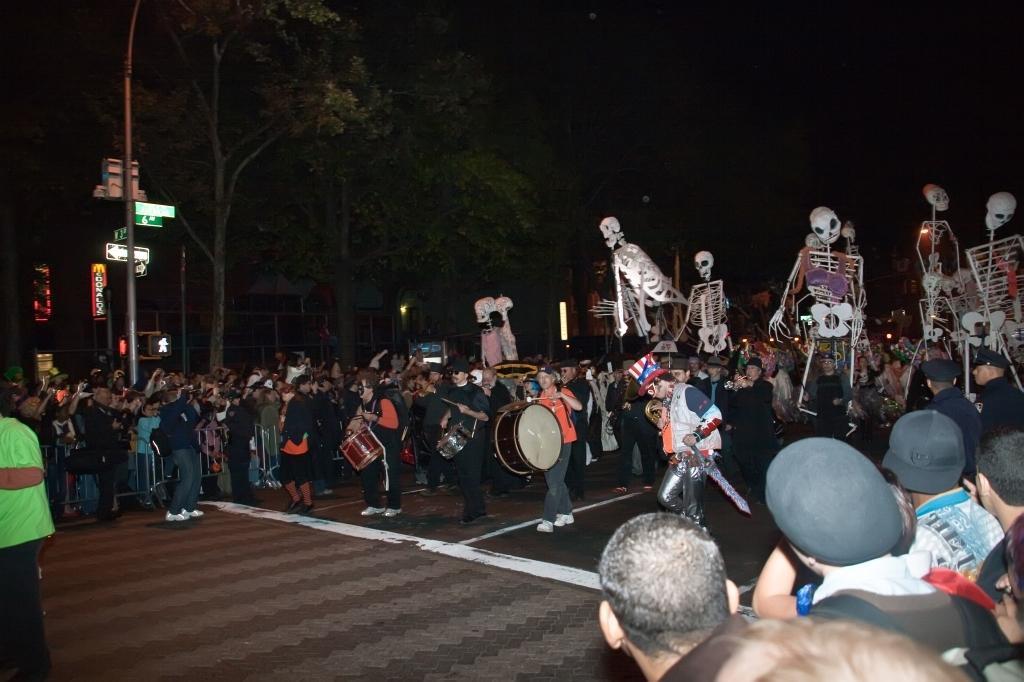Please provide a concise description of this image. In this image we can see many persons standing on the road and holding musical instruments. In the background we can see trees, buildings and sky. 